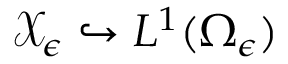Convert formula to latex. <formula><loc_0><loc_0><loc_500><loc_500>\mathcal { X } _ { \epsilon } \hookrightarrow L ^ { 1 } ( \Omega _ { \epsilon } )</formula> 